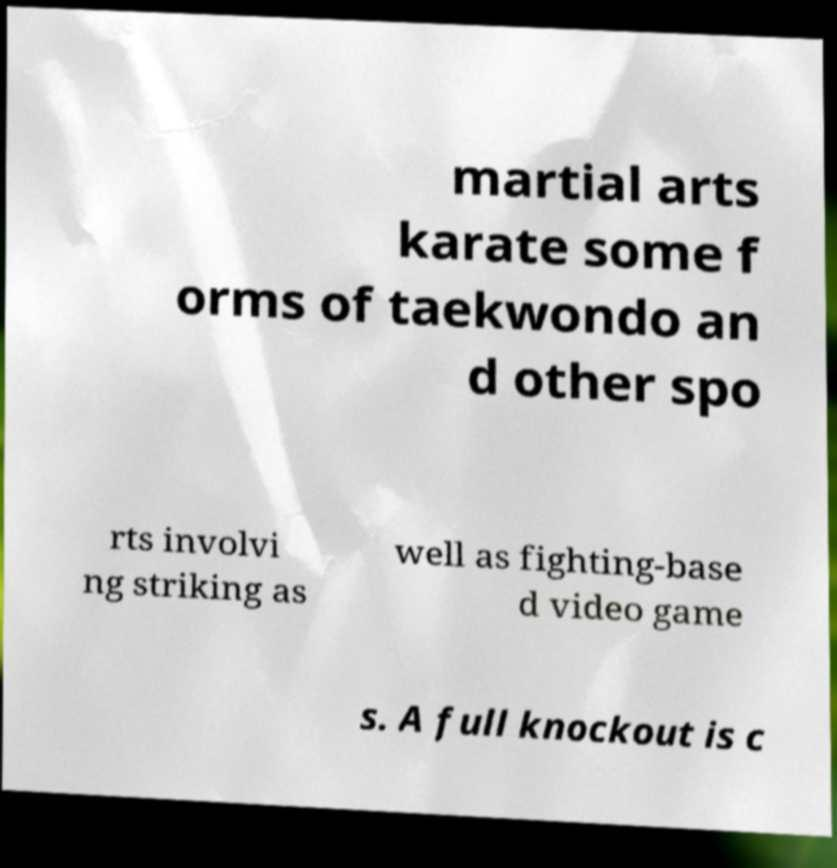Can you accurately transcribe the text from the provided image for me? martial arts karate some f orms of taekwondo an d other spo rts involvi ng striking as well as fighting-base d video game s. A full knockout is c 